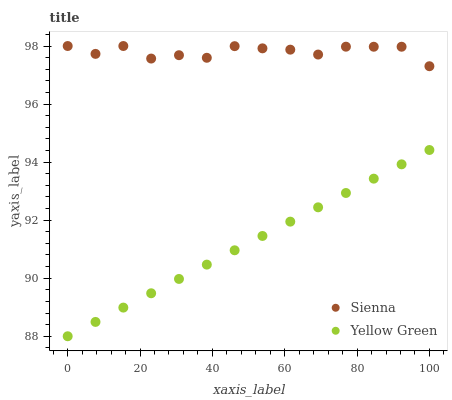Does Yellow Green have the minimum area under the curve?
Answer yes or no. Yes. Does Sienna have the maximum area under the curve?
Answer yes or no. Yes. Does Yellow Green have the maximum area under the curve?
Answer yes or no. No. Is Yellow Green the smoothest?
Answer yes or no. Yes. Is Sienna the roughest?
Answer yes or no. Yes. Is Yellow Green the roughest?
Answer yes or no. No. Does Yellow Green have the lowest value?
Answer yes or no. Yes. Does Sienna have the highest value?
Answer yes or no. Yes. Does Yellow Green have the highest value?
Answer yes or no. No. Is Yellow Green less than Sienna?
Answer yes or no. Yes. Is Sienna greater than Yellow Green?
Answer yes or no. Yes. Does Yellow Green intersect Sienna?
Answer yes or no. No. 